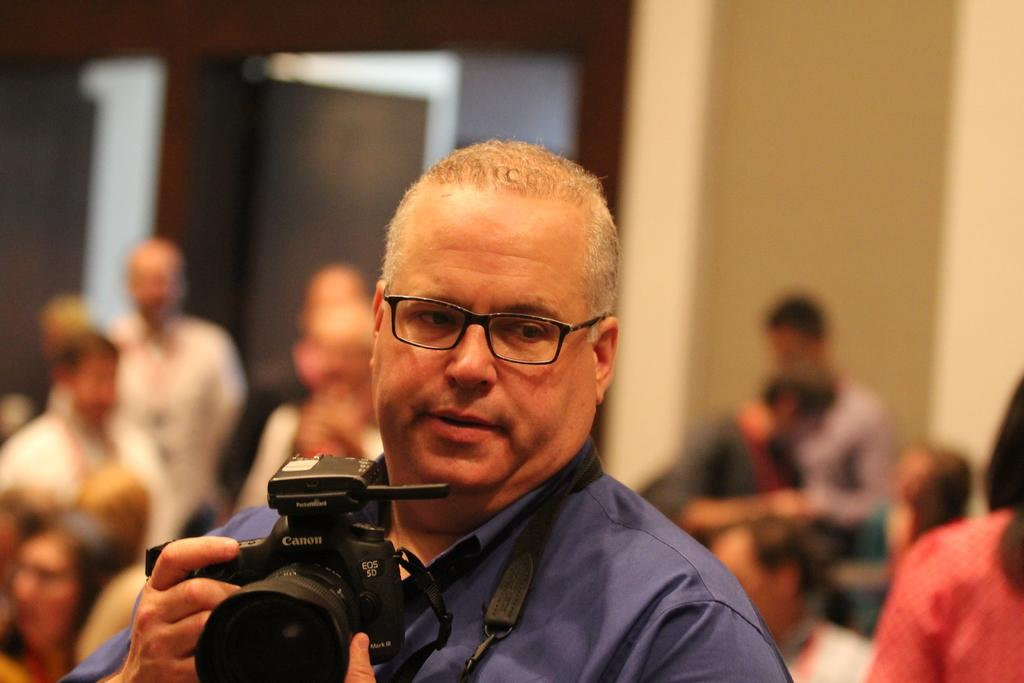Who is present in the image? There is a man in the image. What is the man doing in the image? The man is sitting in the image. What object is the man holding? The man is holding a camera in the image. Can you describe the background of the image? The background of the image is blurry. How many babies are crawling on the man's lap in the image? There are no babies present in the image; it features a man sitting and holding a camera. What type of blade is being used by the man in the image? There is no blade present in the image; the man is holding a camera. 